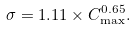Convert formula to latex. <formula><loc_0><loc_0><loc_500><loc_500>\sigma = 1 . 1 1 \times C _ { \max } ^ { 0 . 6 5 } .</formula> 